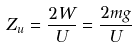Convert formula to latex. <formula><loc_0><loc_0><loc_500><loc_500>Z _ { u } = \frac { 2 W } { U } = \frac { 2 m g } { U }</formula> 